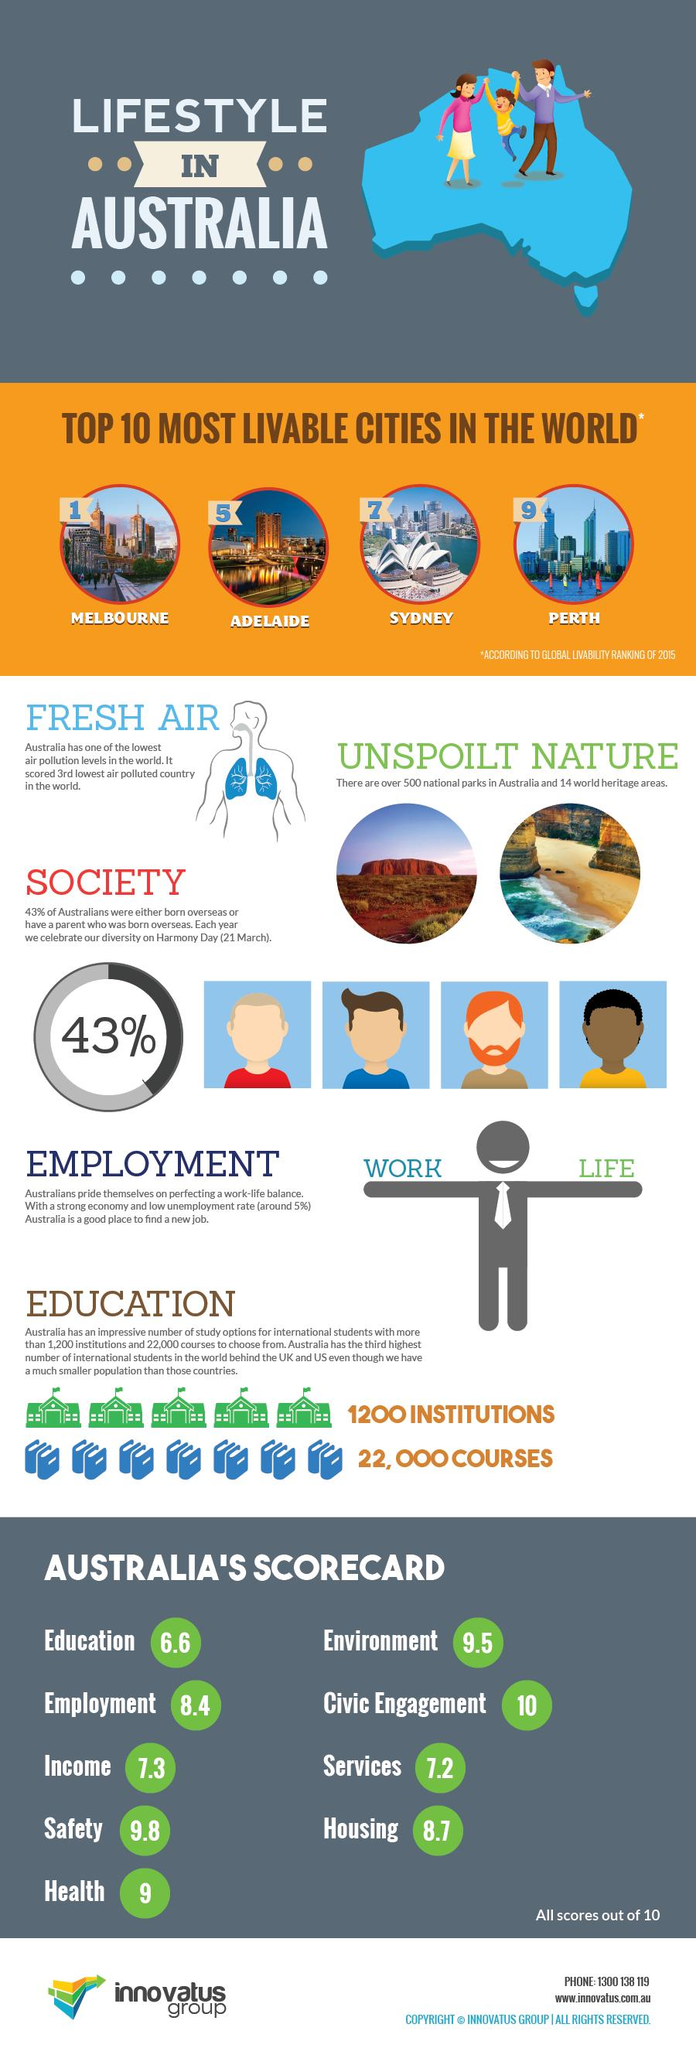Identify some key points in this picture. Australia has the third lowest level of air pollution in the world. Perth is ranked as the ninth most livable city in the world. 